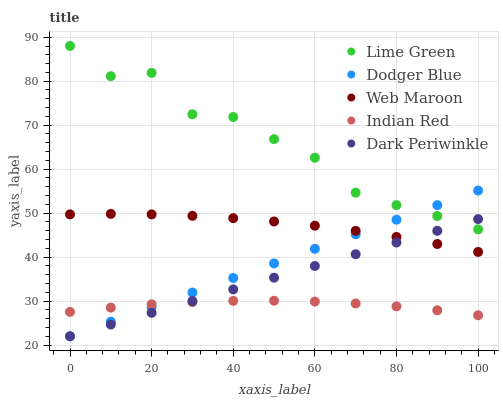Does Indian Red have the minimum area under the curve?
Answer yes or no. Yes. Does Lime Green have the maximum area under the curve?
Answer yes or no. Yes. Does Lime Green have the minimum area under the curve?
Answer yes or no. No. Does Indian Red have the maximum area under the curve?
Answer yes or no. No. Is Dark Periwinkle the smoothest?
Answer yes or no. Yes. Is Lime Green the roughest?
Answer yes or no. Yes. Is Indian Red the smoothest?
Answer yes or no. No. Is Indian Red the roughest?
Answer yes or no. No. Does Dodger Blue have the lowest value?
Answer yes or no. Yes. Does Indian Red have the lowest value?
Answer yes or no. No. Does Lime Green have the highest value?
Answer yes or no. Yes. Does Indian Red have the highest value?
Answer yes or no. No. Is Web Maroon less than Lime Green?
Answer yes or no. Yes. Is Lime Green greater than Web Maroon?
Answer yes or no. Yes. Does Lime Green intersect Dark Periwinkle?
Answer yes or no. Yes. Is Lime Green less than Dark Periwinkle?
Answer yes or no. No. Is Lime Green greater than Dark Periwinkle?
Answer yes or no. No. Does Web Maroon intersect Lime Green?
Answer yes or no. No. 